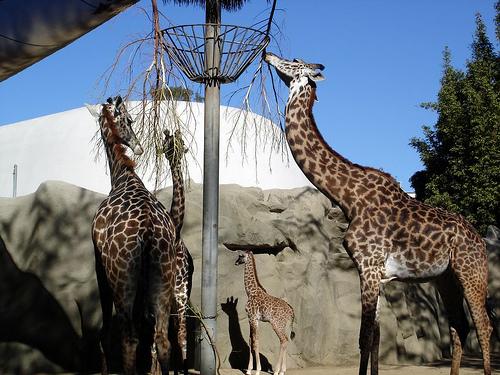How many animals?
Short answer required. 4. What is the purpose of the basket in this image?
Quick response, please. Feed. Are the giraffes in the wild?
Short answer required. No. Are the giraffe eating?
Give a very brief answer. Yes. 